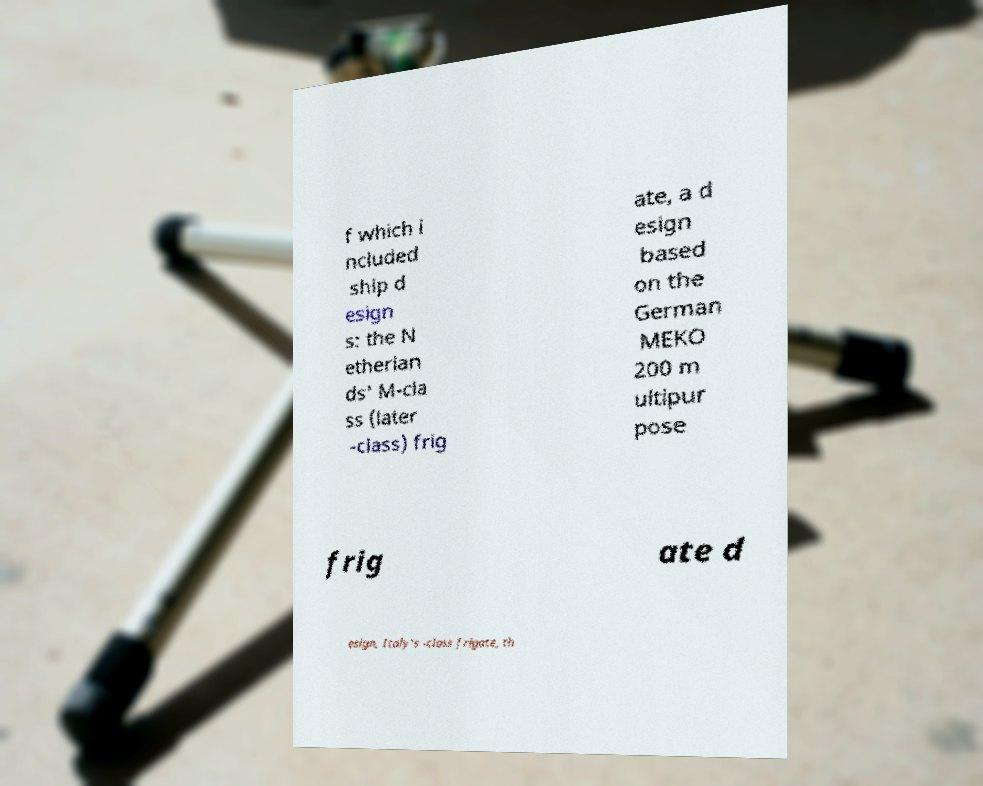Could you extract and type out the text from this image? f which i ncluded ship d esign s: the N etherlan ds' M-cla ss (later -class) frig ate, a d esign based on the German MEKO 200 m ultipur pose frig ate d esign, Italy's -class frigate, th 